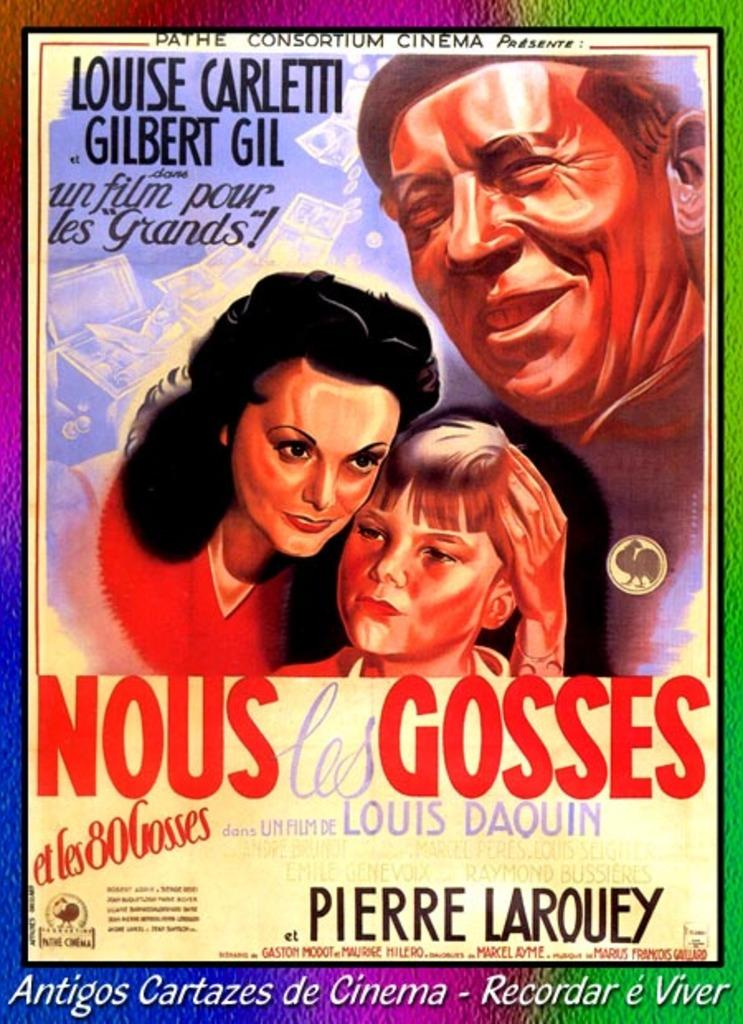Provide a one-sentence caption for the provided image. A poster for a old foreign movie called Nous Les Gosses which has a women, child and man on the poster. 